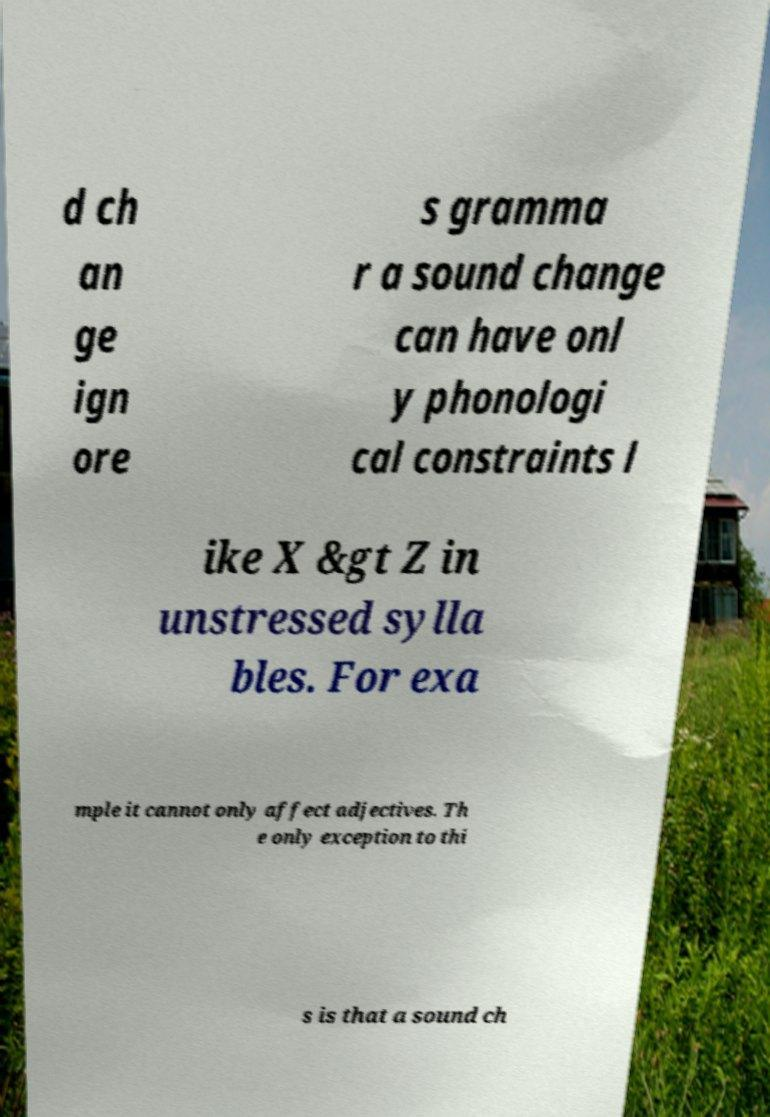Can you accurately transcribe the text from the provided image for me? d ch an ge ign ore s gramma r a sound change can have onl y phonologi cal constraints l ike X &gt Z in unstressed sylla bles. For exa mple it cannot only affect adjectives. Th e only exception to thi s is that a sound ch 